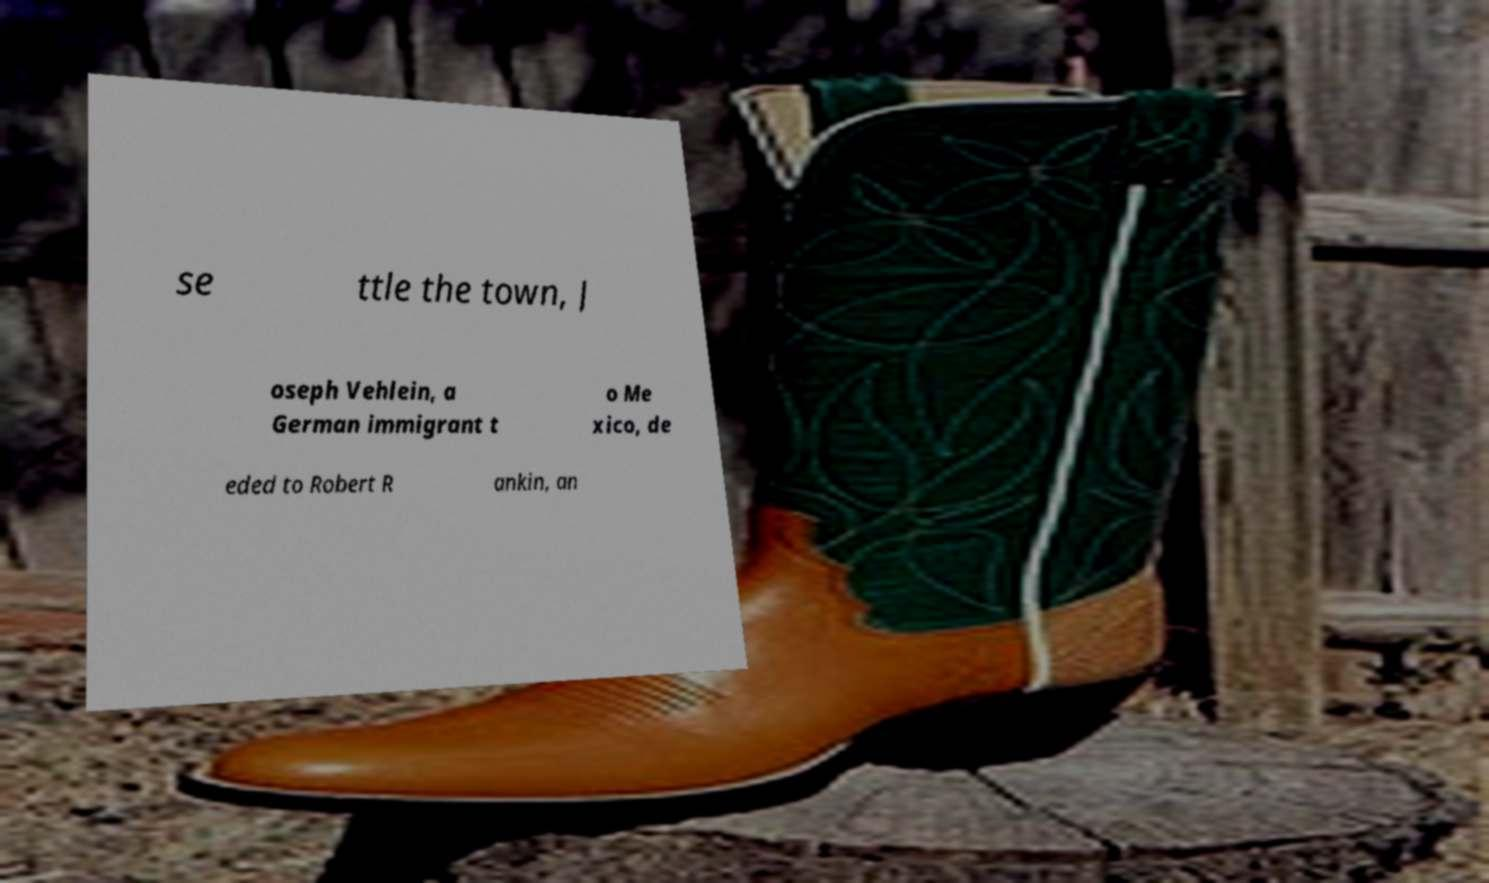There's text embedded in this image that I need extracted. Can you transcribe it verbatim? se ttle the town, J oseph Vehlein, a German immigrant t o Me xico, de eded to Robert R ankin, an 